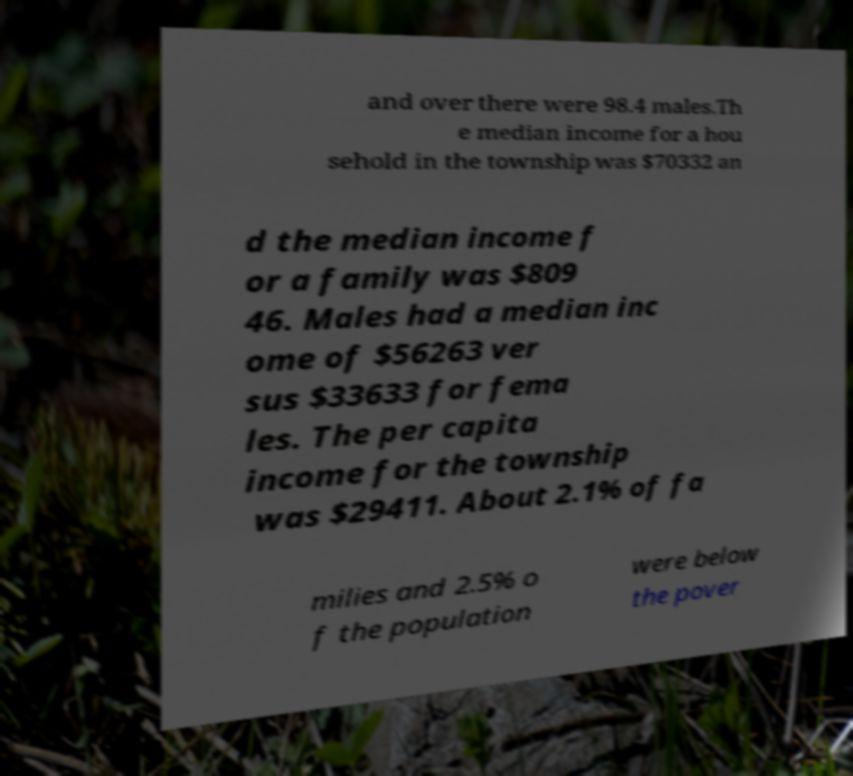Could you assist in decoding the text presented in this image and type it out clearly? and over there were 98.4 males.Th e median income for a hou sehold in the township was $70332 an d the median income f or a family was $809 46. Males had a median inc ome of $56263 ver sus $33633 for fema les. The per capita income for the township was $29411. About 2.1% of fa milies and 2.5% o f the population were below the pover 